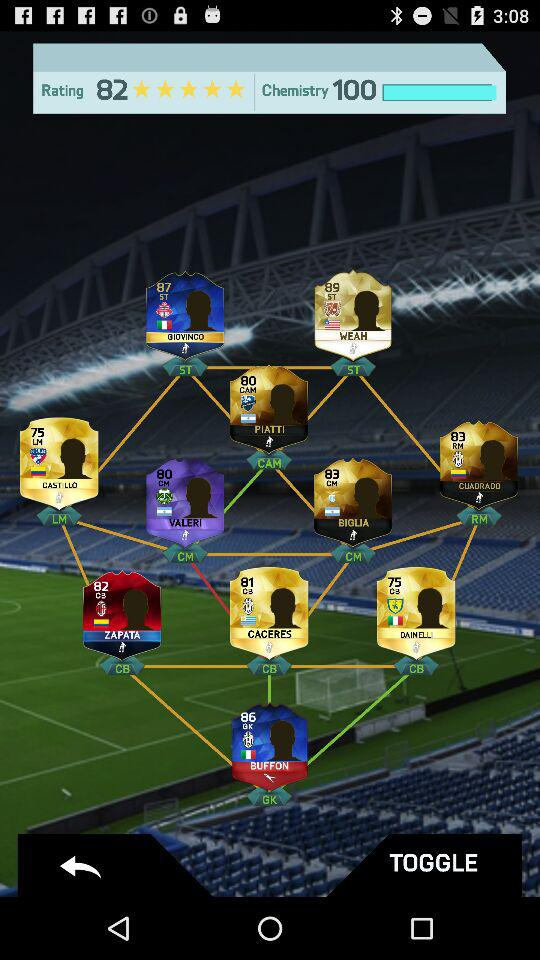What is the name of the application?
When the provided information is insufficient, respond with <no answer>. <no answer> 